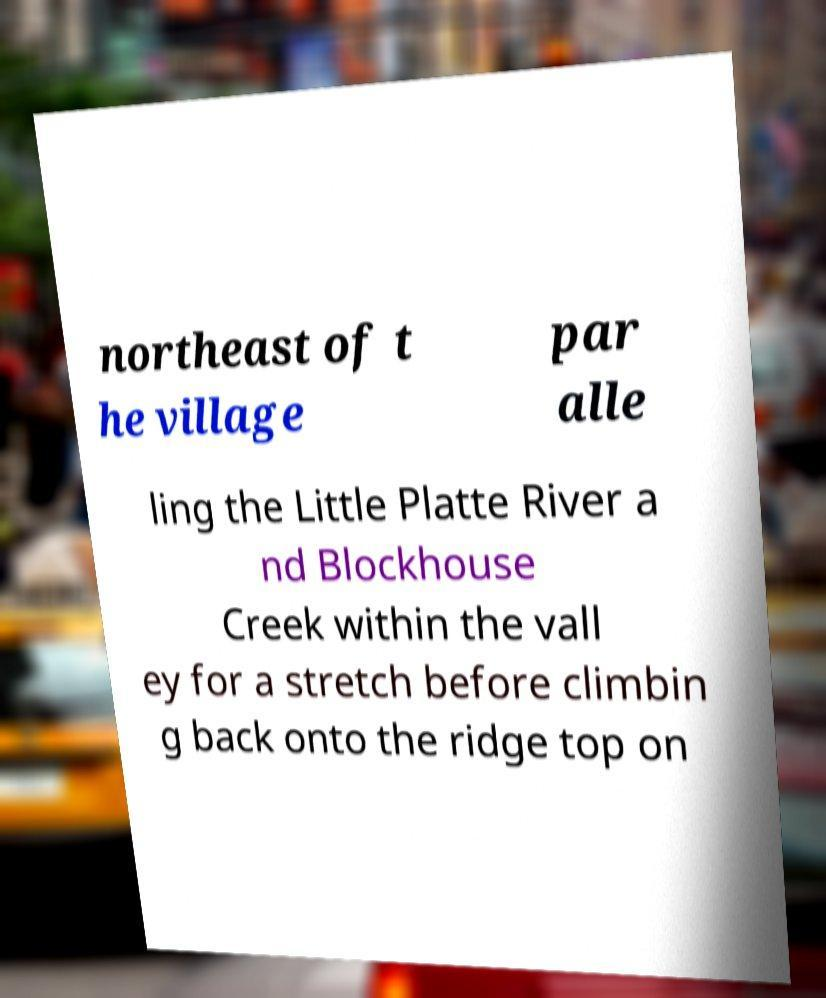Could you assist in decoding the text presented in this image and type it out clearly? northeast of t he village par alle ling the Little Platte River a nd Blockhouse Creek within the vall ey for a stretch before climbin g back onto the ridge top on 